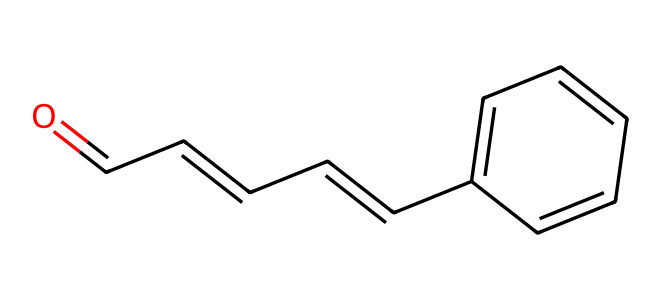What is the molecular formula of cinnamaldehyde? To determine the molecular formula, you can count the number of carbon (C), hydrogen (H), and oxygen (O) atoms in the provided SMILES representation. There are 9 carbon atoms, 8 hydrogen atoms, and 1 oxygen atom. Therefore, the molecular formula is C9H8O.
Answer: C9H8O How many double bonds are present in cinnamaldehyde? In the SMILES code, the presence of "=" indicates double bonds. By examining the structure, there are 3 instances of double bonds in the carbon chain and one with the oxygen (C=O), totaling 4 double bonds.
Answer: 4 What functional group characterizes cinnamaldehyde? The presence of the carbonyl group (C=O) at the beginning of the structure suggests that cinnamaldehyde belongs to the aldehyde functional group. The -CHO group confirms its classification.
Answer: aldehyde Which part of the molecule provides its characteristic flavor? The aldehyde group (C=O) along with the ethylene group (the double bonds) in the aliphatic chain contribute to the characteristic flavor of cinnamon. This specific arrangement leads to the unique aromatic profile typical of cinnamaldehyde.
Answer: aldehyde How many rings are present in the structure of cinnamaldehyde? By examining the SMILES representation, there is one ring indicated by the presence of "C1" at the beginning and "C1" again which closes the ring structure in the representation. Thus, there is one cyclic part in the structure.
Answer: 1 What type of chemical is cinnamaldehyde classified as in terms of its usage? Cinnamaldehyde is primarily used as a flavoring agent due to its aromatic properties. It is commonly referred to as a natural flavoring compound found in cinnamon. Its structure contributes directly to its flavor profile, making it essential in culinary applications.
Answer: flavoring agent 